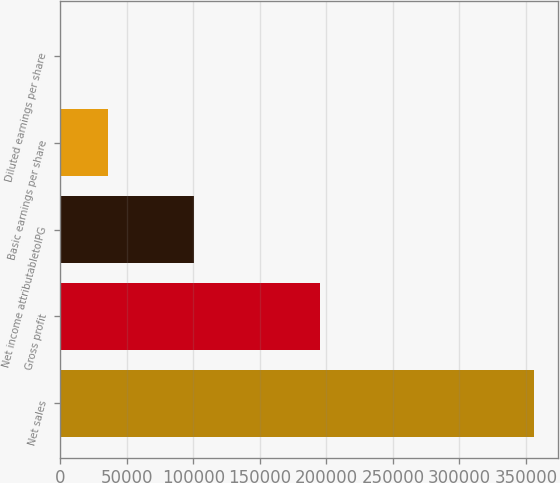Convert chart. <chart><loc_0><loc_0><loc_500><loc_500><bar_chart><fcel>Net sales<fcel>Gross profit<fcel>Net income attributabletoIPG<fcel>Basic earnings per share<fcel>Diluted earnings per share<nl><fcel>356346<fcel>195184<fcel>100517<fcel>35636.3<fcel>1.84<nl></chart> 